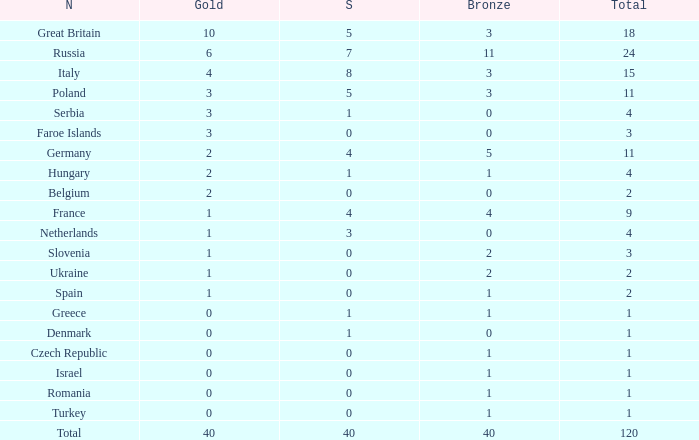What is the average Gold entry for the Netherlands that also has a Bronze entry that is greater than 0? None. 